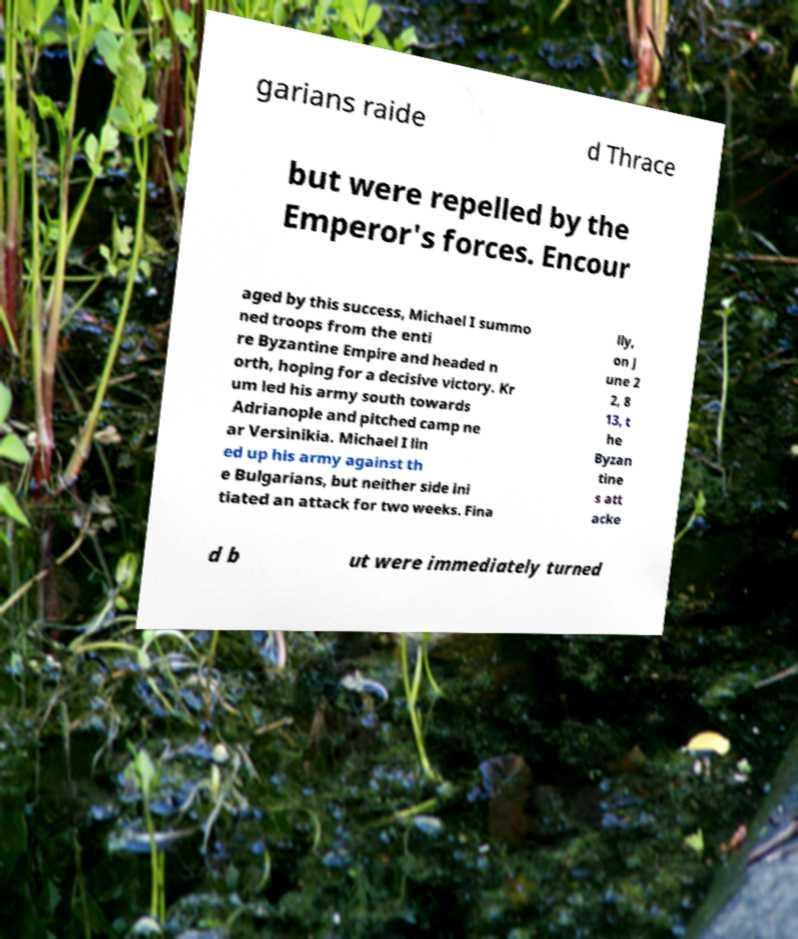Can you read and provide the text displayed in the image?This photo seems to have some interesting text. Can you extract and type it out for me? garians raide d Thrace but were repelled by the Emperor's forces. Encour aged by this success, Michael I summo ned troops from the enti re Byzantine Empire and headed n orth, hoping for a decisive victory. Kr um led his army south towards Adrianople and pitched camp ne ar Versinikia. Michael I lin ed up his army against th e Bulgarians, but neither side ini tiated an attack for two weeks. Fina lly, on J une 2 2, 8 13, t he Byzan tine s att acke d b ut were immediately turned 